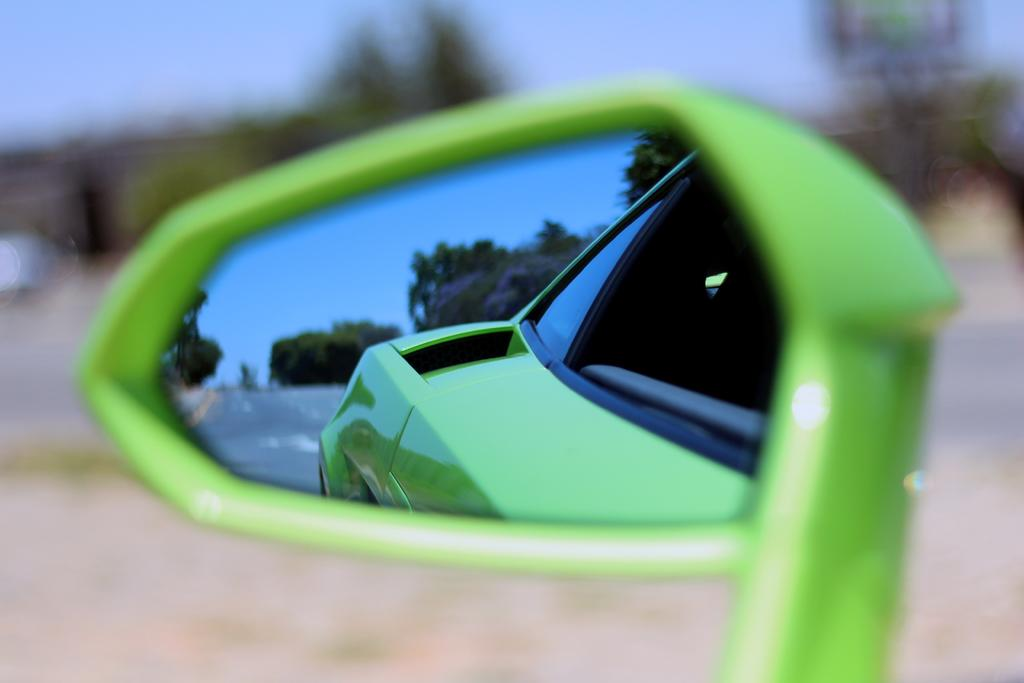What is the main feature of the background in the image? The background portion of the picture is blurred. What object is present in the image that allows for reflections? There is a mirror in the image. What can be seen in the mirror's reflection? The reflection of the sky, trees, a road, and a partial reflection of a vehicle are visible in the mirror. What type of plastic cart is visible in the image? There is no plastic cart present in the image. Can you touch the reflection of the sky in the mirror? Reflections in a mirror are not tangible, so you cannot touch the reflection of the sky in the image. 